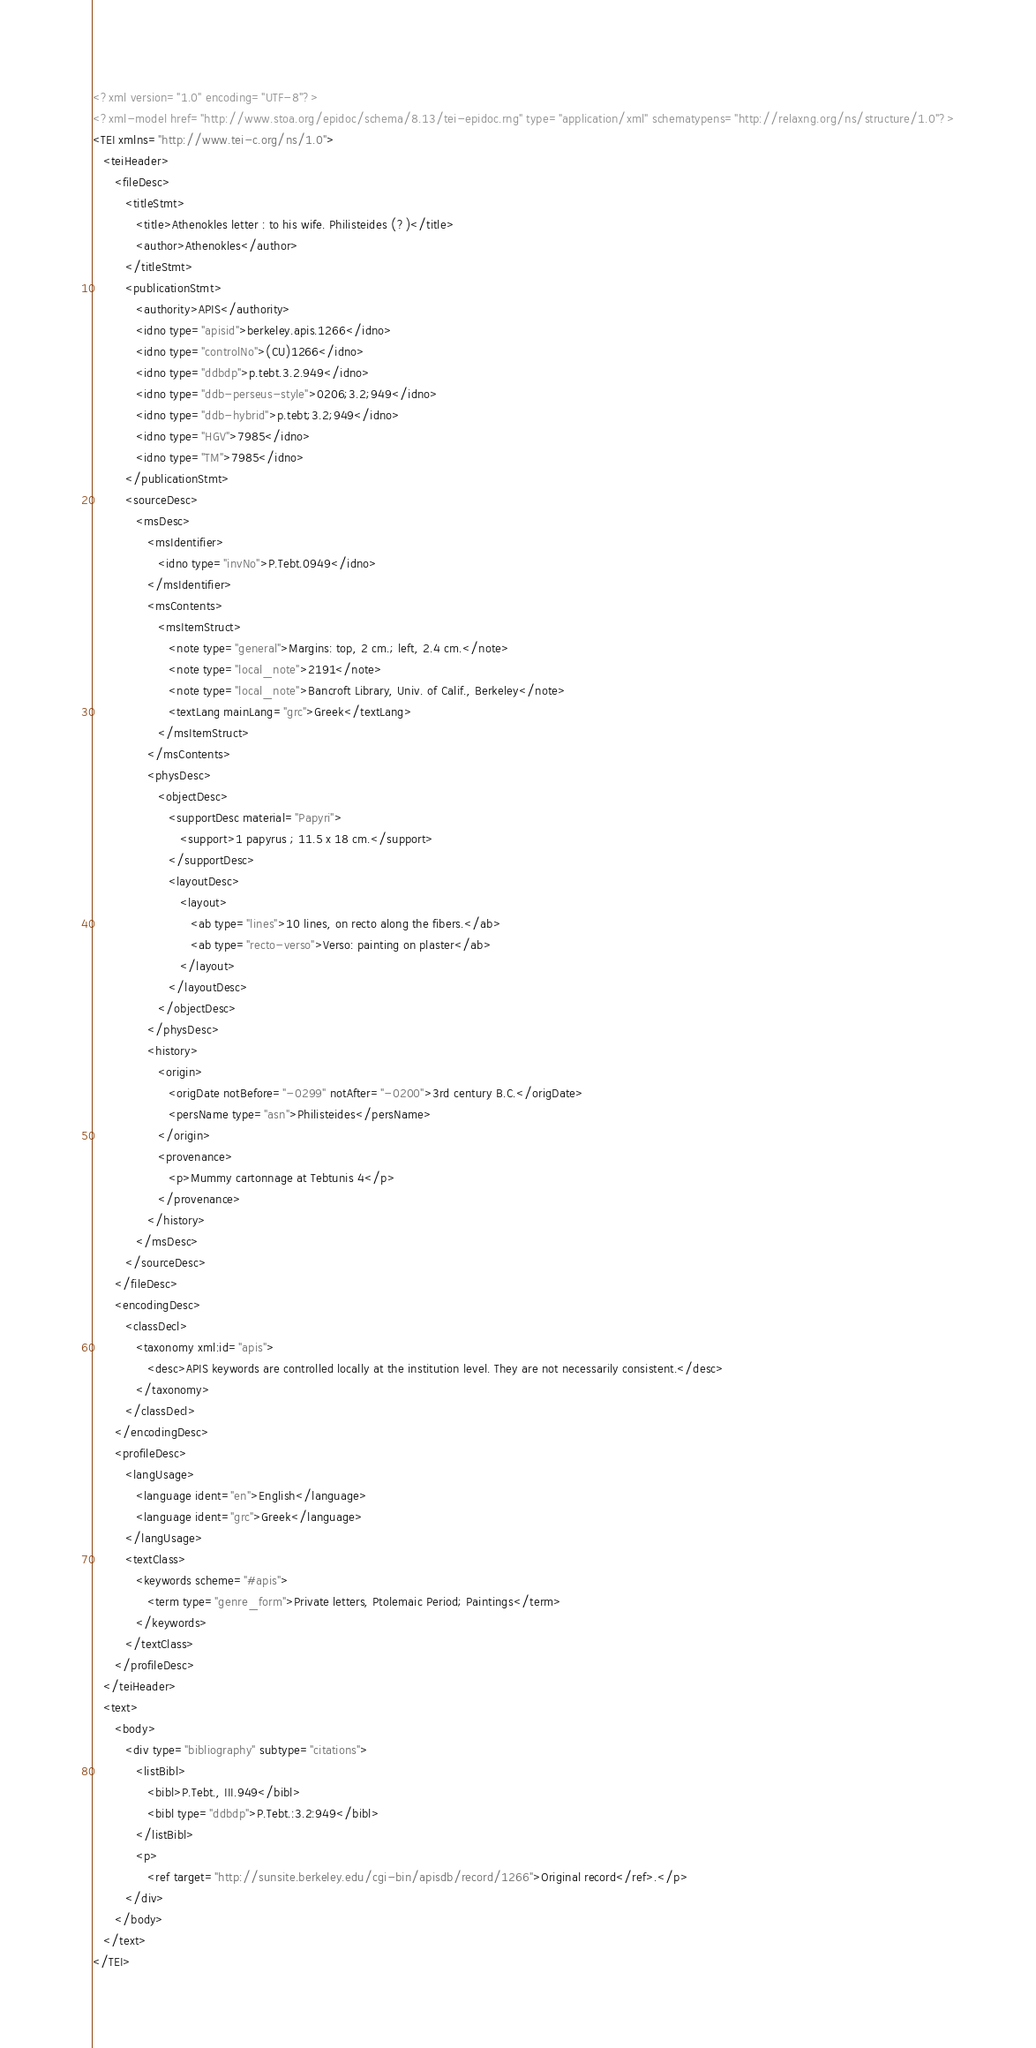Convert code to text. <code><loc_0><loc_0><loc_500><loc_500><_XML_><?xml version="1.0" encoding="UTF-8"?>
<?xml-model href="http://www.stoa.org/epidoc/schema/8.13/tei-epidoc.rng" type="application/xml" schematypens="http://relaxng.org/ns/structure/1.0"?>
<TEI xmlns="http://www.tei-c.org/ns/1.0">
   <teiHeader>
      <fileDesc>
         <titleStmt>
            <title>Athenokles letter : to his wife. Philisteides (?)</title>
            <author>Athenokles</author>
         </titleStmt>
         <publicationStmt>
            <authority>APIS</authority>
            <idno type="apisid">berkeley.apis.1266</idno>
            <idno type="controlNo">(CU)1266</idno>
            <idno type="ddbdp">p.tebt.3.2.949</idno>
            <idno type="ddb-perseus-style">0206;3.2;949</idno>
            <idno type="ddb-hybrid">p.tebt;3.2;949</idno>
            <idno type="HGV">7985</idno>
            <idno type="TM">7985</idno>
         </publicationStmt>
         <sourceDesc>
            <msDesc>
               <msIdentifier>
                  <idno type="invNo">P.Tebt.0949</idno>
               </msIdentifier>
               <msContents>
                  <msItemStruct>
                     <note type="general">Margins: top, 2 cm.; left, 2.4 cm.</note>
                     <note type="local_note">2191</note>
                     <note type="local_note">Bancroft Library, Univ. of Calif., Berkeley</note>
                     <textLang mainLang="grc">Greek</textLang>
                  </msItemStruct>
               </msContents>
               <physDesc>
                  <objectDesc>
                     <supportDesc material="Papyri">
                        <support>1 papyrus ; 11.5 x 18 cm.</support>
                     </supportDesc>
                     <layoutDesc>
                        <layout>
                           <ab type="lines">10 lines, on recto along the fibers.</ab>
                           <ab type="recto-verso">Verso: painting on plaster</ab>
                        </layout>
                     </layoutDesc>
                  </objectDesc>
               </physDesc>
               <history>
                  <origin>
                     <origDate notBefore="-0299" notAfter="-0200">3rd century B.C.</origDate>
                     <persName type="asn">Philisteides</persName>
                  </origin>
                  <provenance>
                     <p>Mummy cartonnage at Tebtunis 4</p>
                  </provenance>
               </history>
            </msDesc>
         </sourceDesc>
      </fileDesc>
      <encodingDesc>
         <classDecl>
            <taxonomy xml:id="apis">
               <desc>APIS keywords are controlled locally at the institution level. They are not necessarily consistent.</desc>
            </taxonomy>
         </classDecl>
      </encodingDesc>
      <profileDesc>
         <langUsage>
            <language ident="en">English</language>
            <language ident="grc">Greek</language>
         </langUsage>
         <textClass>
            <keywords scheme="#apis">
               <term type="genre_form">Private letters, Ptolemaic Period; Paintings</term>
            </keywords>
         </textClass>
      </profileDesc>
   </teiHeader>
   <text>
      <body>
         <div type="bibliography" subtype="citations">
            <listBibl>
               <bibl>P.Tebt., III.949</bibl>
               <bibl type="ddbdp">P.Tebt.:3.2:949</bibl>
            </listBibl>
            <p>
               <ref target="http://sunsite.berkeley.edu/cgi-bin/apisdb/record/1266">Original record</ref>.</p>
         </div>
      </body>
   </text>
</TEI></code> 